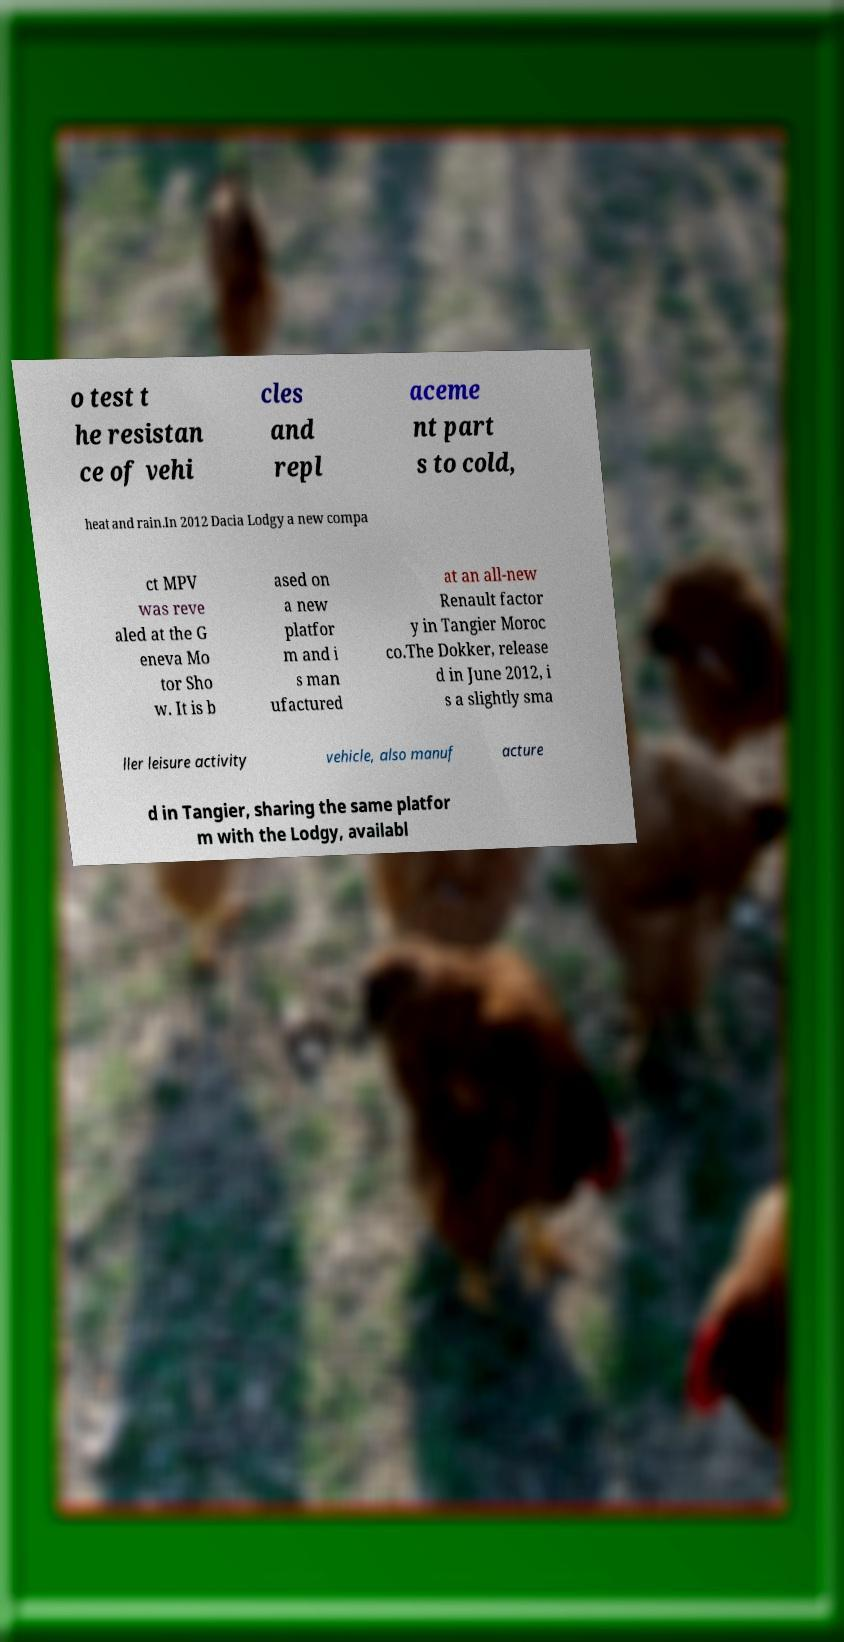Please read and relay the text visible in this image. What does it say? o test t he resistan ce of vehi cles and repl aceme nt part s to cold, heat and rain.In 2012 Dacia Lodgy a new compa ct MPV was reve aled at the G eneva Mo tor Sho w. It is b ased on a new platfor m and i s man ufactured at an all-new Renault factor y in Tangier Moroc co.The Dokker, release d in June 2012, i s a slightly sma ller leisure activity vehicle, also manuf acture d in Tangier, sharing the same platfor m with the Lodgy, availabl 